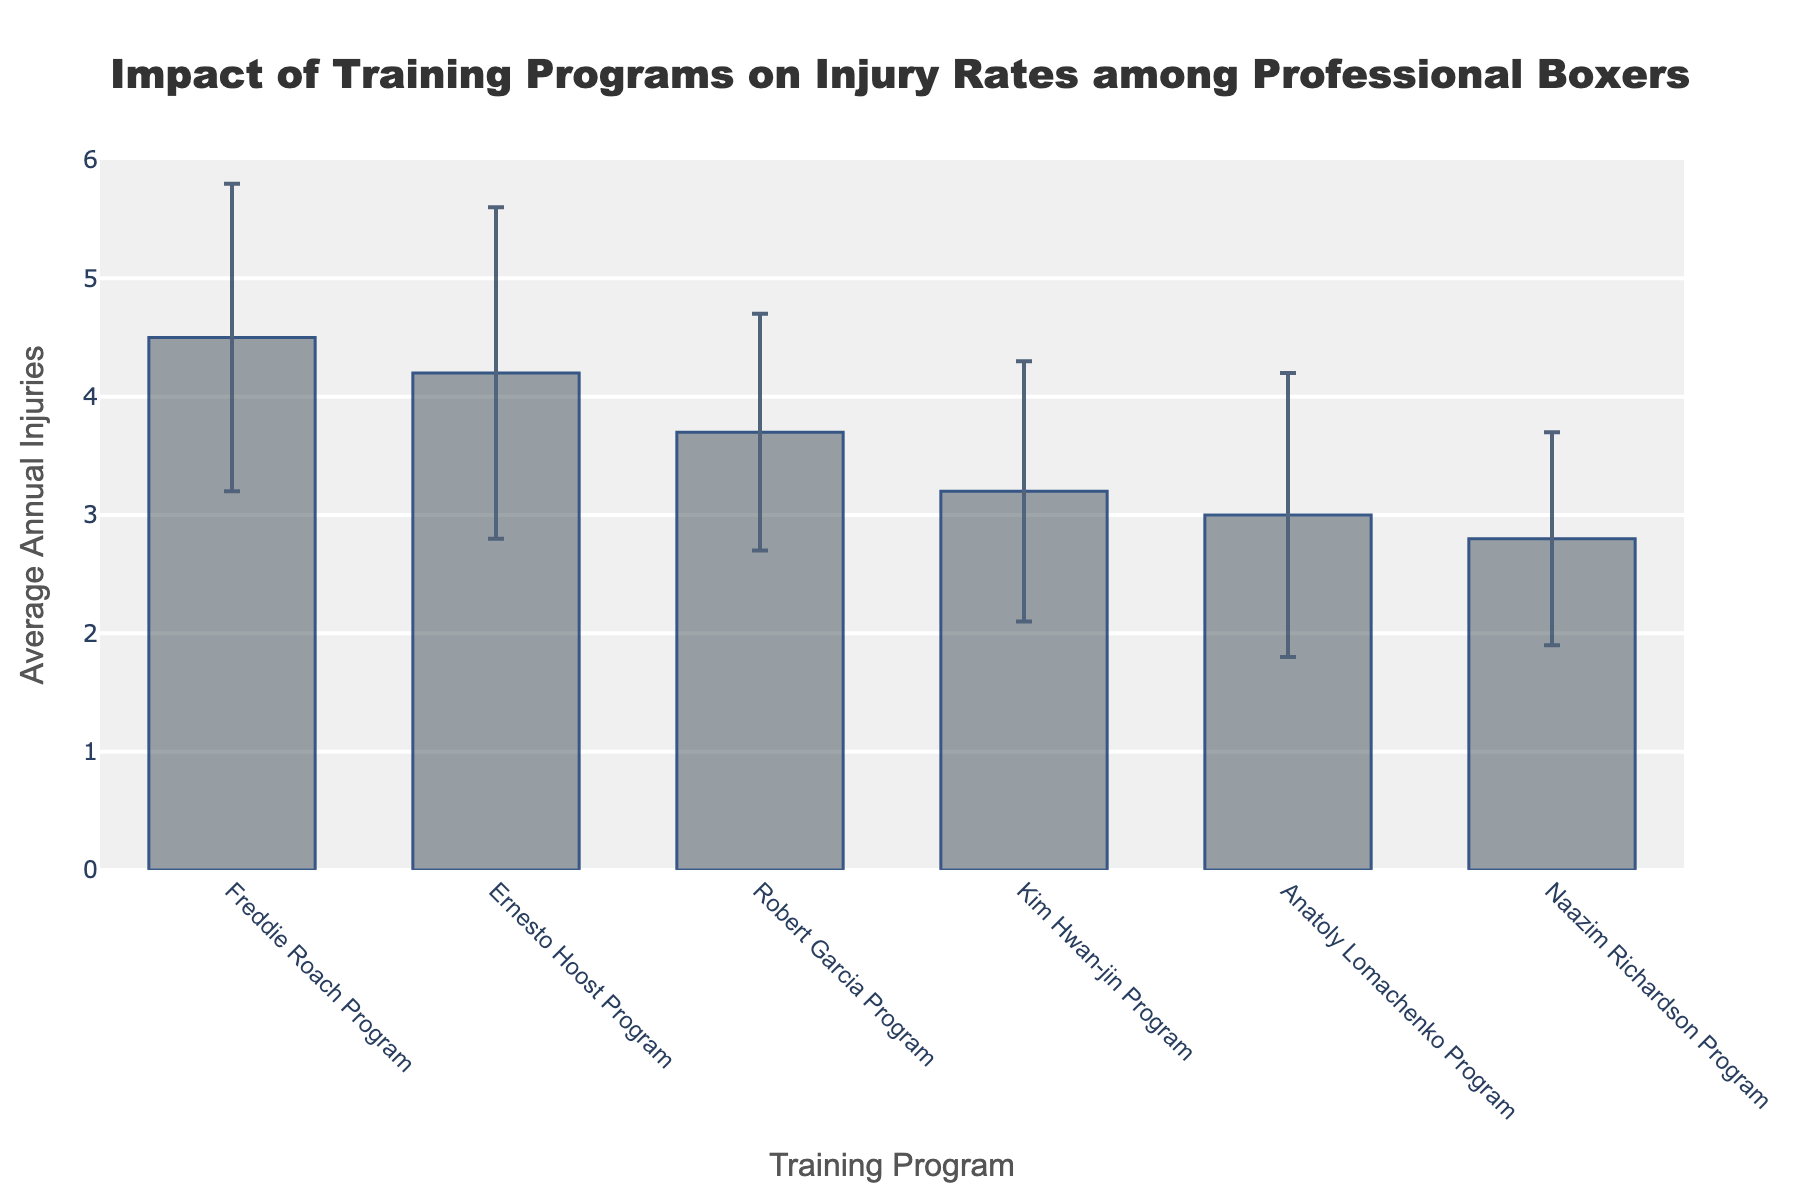What's the title of the bar chart? The title of the figure is displayed at the top of the chart, specifying the purpose and focus of the chart.
Answer: Impact of Training Programs on Injury Rates among Professional Boxers Which training program has the highest average annual injuries? By inspecting the height of the bars, the Freddie Roach Program has the highest average annual injuries of 4.5.
Answer: Freddie Roach Program How many training programs are compared in the chart? Count the number of bars, each representing a training program. There are six bars in total.
Answer: 6 programs What is the average annual injury rate for the Naazim Richardson Program? The height of the bar representing the Naazim Richardson Program gives the average annual injuries, which is 2.8.
Answer: 2.8 injuries Which training program has the lowest average annual injuries? By observing the heights of the bars, the Naazim Richardson Program has the lowest average annual injuries of 2.8.
Answer: Naazim Richardson Program Compare the average annual injuries between the Kim Hwan-jin Program and the Ernesto Hoost Program. Which one has more, and by how much? The Kim Hwan-jin Program has 3.2 average annual injuries, and the Ernesto Hoost Program has 4.2. Subtracting 3.2 from 4.2 gives the difference.
Answer: Ernesto Hoost Program by 1 What is the difference in average annual injuries between the training program with the highest rate and the one with the lowest rate? The highest rate is from the Freddie Roach Program (4.5), and the lowest is from the Naazim Richardson Program (2.8). Subtract 2.8 from 4.5.
Answer: 1.7 injuries Which training programs have an average annual injury rate between 3 and 4? The bars for the Kim Hwan-jin, Robert Garcia, and Anatoly Lomachenko Programs fall within this range.
Answer: Kim Hwan-jin, Robert Garcia, Anatoly Lomachenko Is the average annual injury rate of the Robert Garcia Program greater than that of the Anatoly Lomachenko Program? The bar for the Robert Garcia Program shows 3.7, while the bar for the Anatoly Lomachenko Program shows 3.0. Comparing these values confirms that 3.7 is greater than 3.0.
Answer: Yes What error bars are shown for the Freddie Roach Program, and what do they represent? The error bars on the Freddie Roach Program show the standard deviation, which is 1.3. This represents the variability or spread of the annual injury data around the average value of 4.5.
Answer: 1.3 standard deviation 